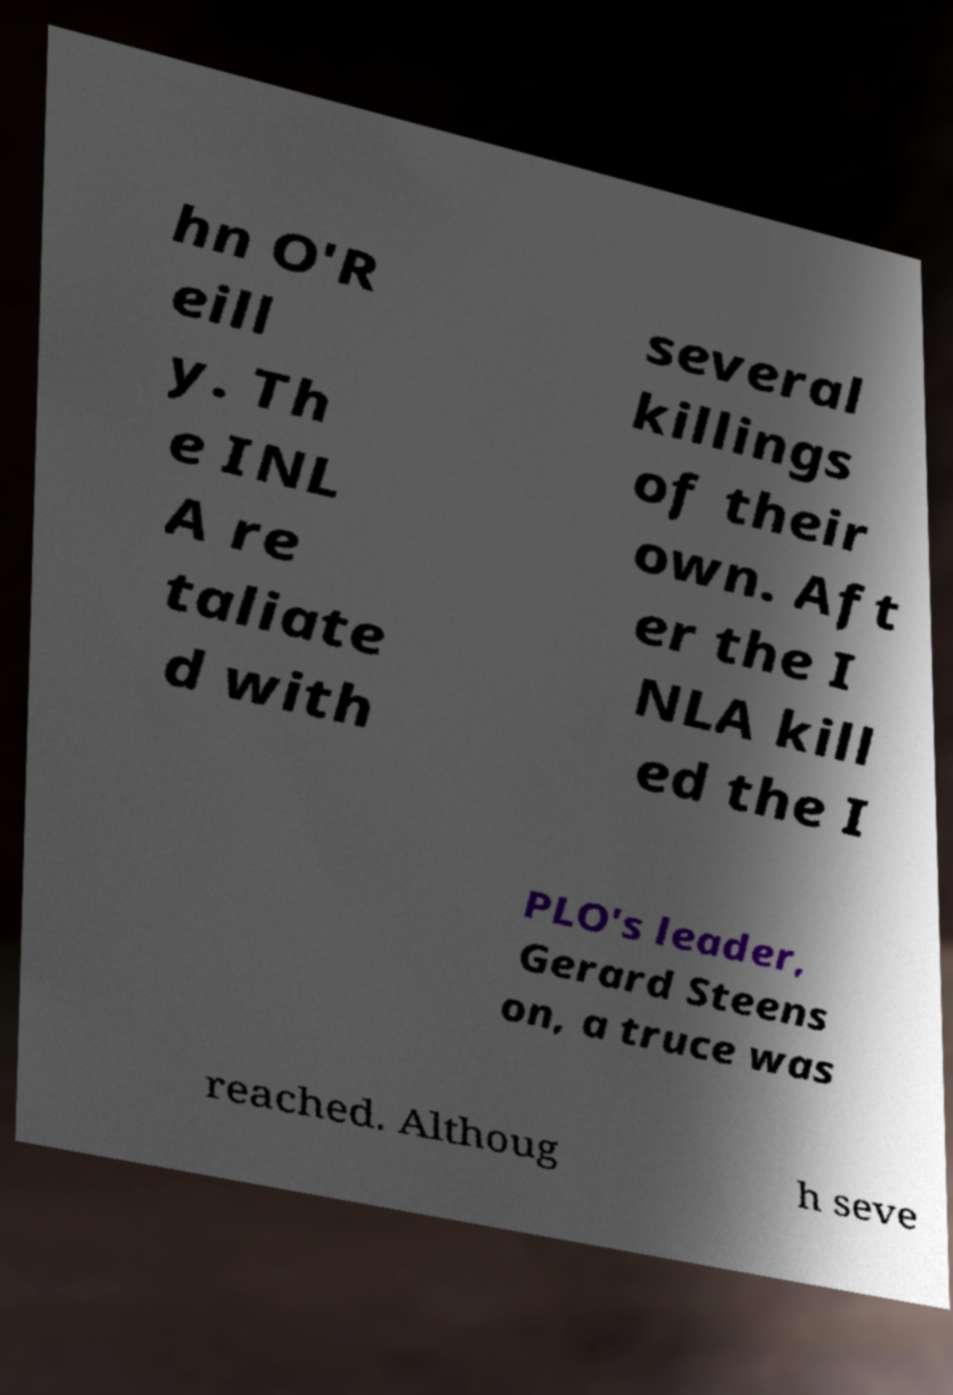I need the written content from this picture converted into text. Can you do that? hn O'R eill y. Th e INL A re taliate d with several killings of their own. Aft er the I NLA kill ed the I PLO's leader, Gerard Steens on, a truce was reached. Althoug h seve 